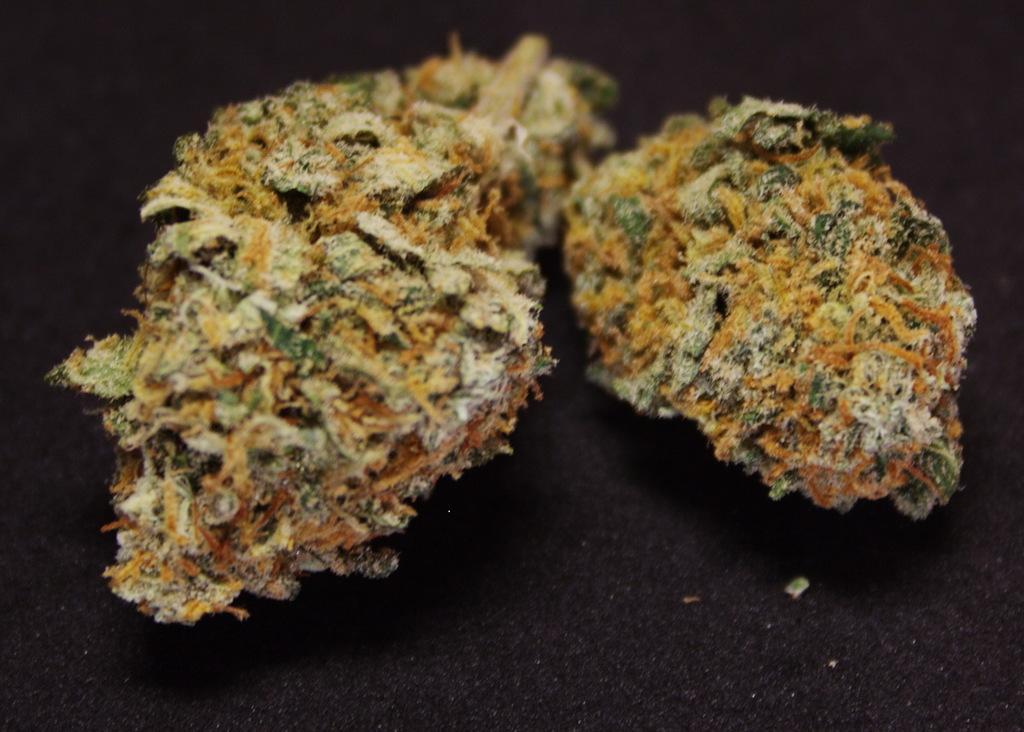Can you describe this image briefly? In this image we can see some objects which are in yellow and green color are placed on the black surface. The background of the image is in black color. 